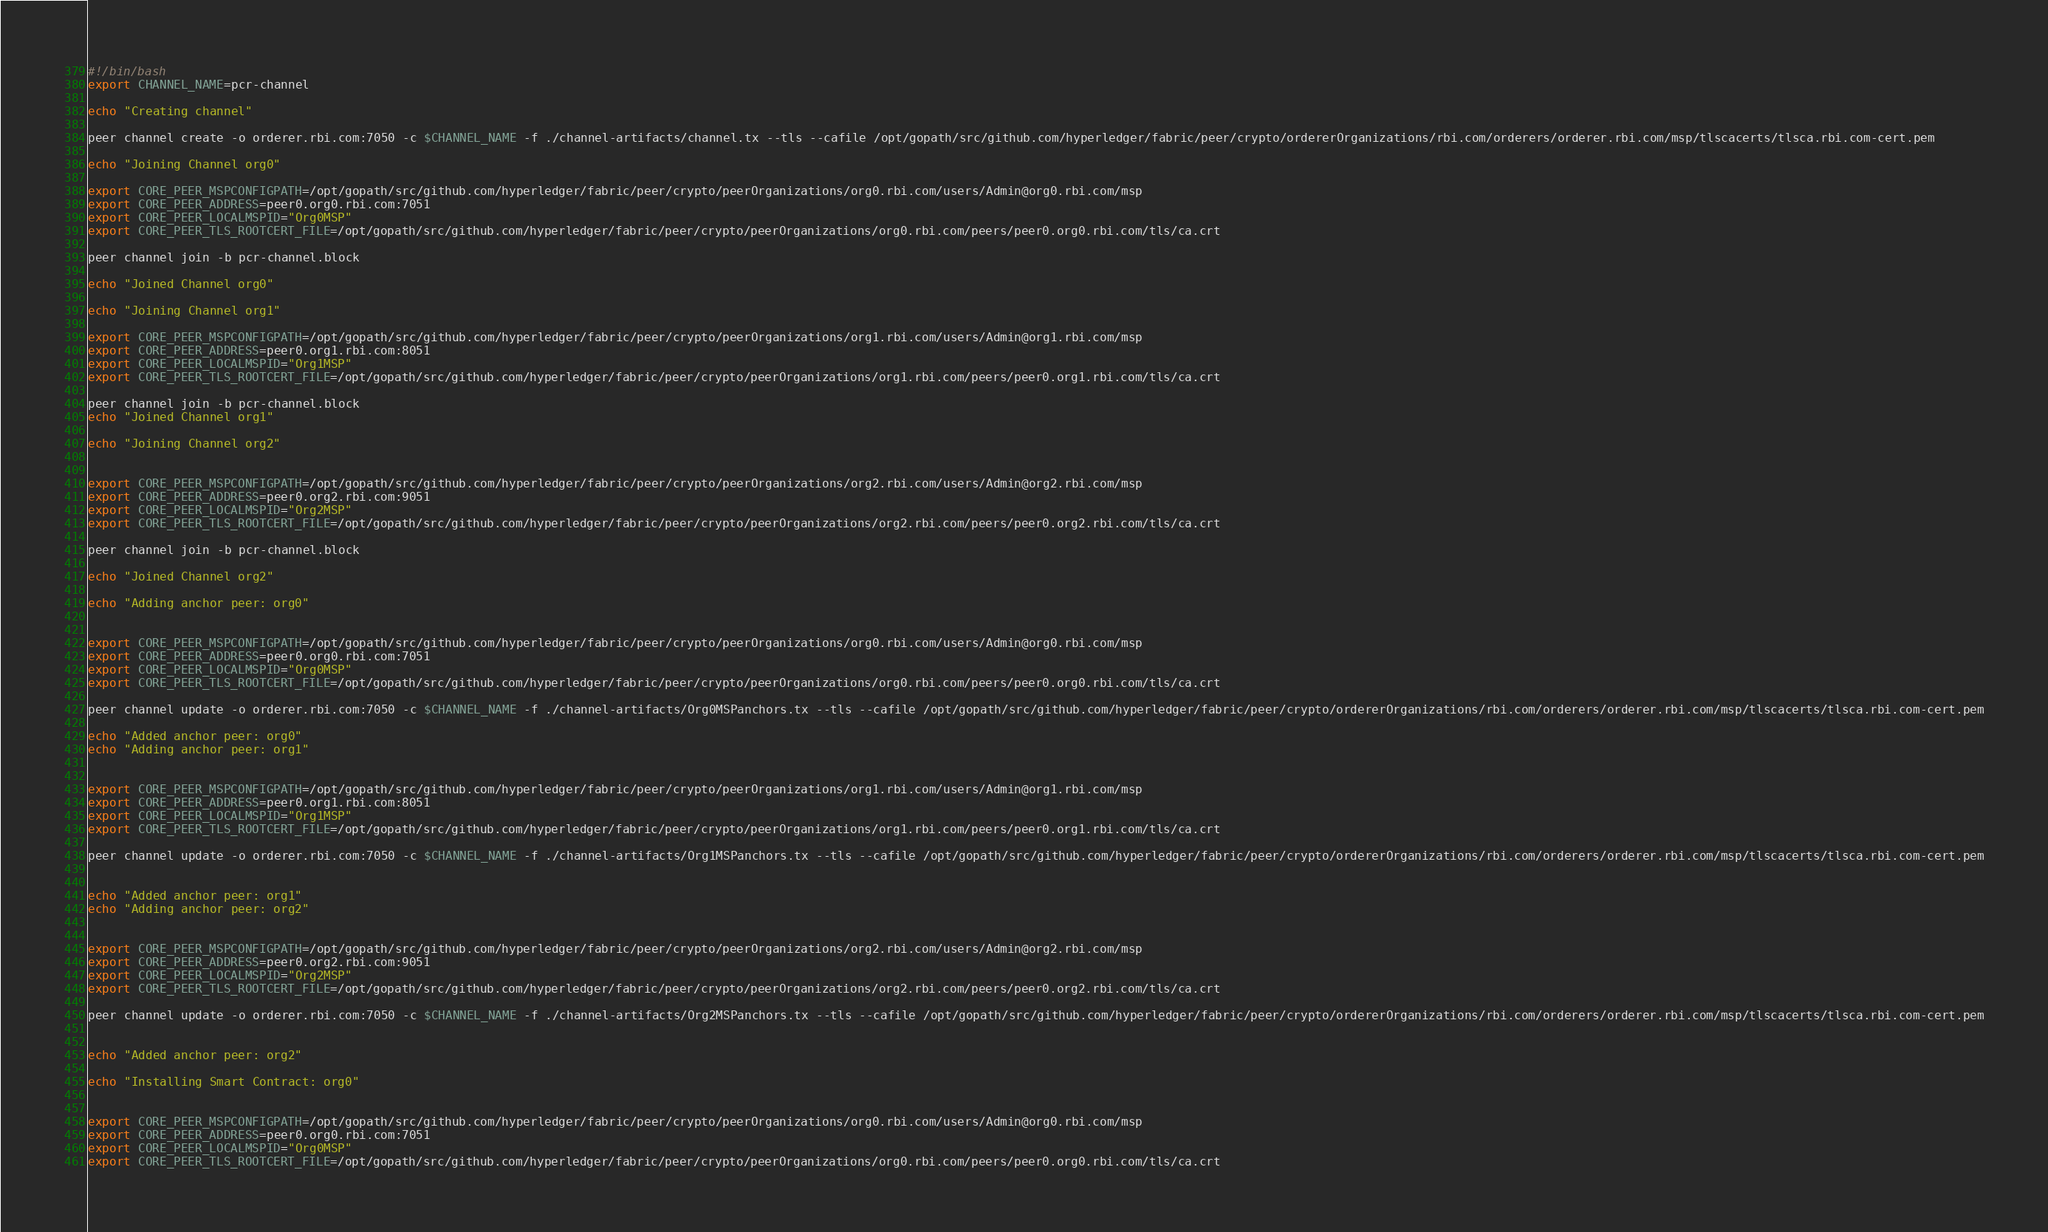<code> <loc_0><loc_0><loc_500><loc_500><_Bash_>#!/bin/bash
export CHANNEL_NAME=pcr-channel

echo "Creating channel"

peer channel create -o orderer.rbi.com:7050 -c $CHANNEL_NAME -f ./channel-artifacts/channel.tx --tls --cafile /opt/gopath/src/github.com/hyperledger/fabric/peer/crypto/ordererOrganizations/rbi.com/orderers/orderer.rbi.com/msp/tlscacerts/tlsca.rbi.com-cert.pem

echo "Joining Channel org0"

export CORE_PEER_MSPCONFIGPATH=/opt/gopath/src/github.com/hyperledger/fabric/peer/crypto/peerOrganizations/org0.rbi.com/users/Admin@org0.rbi.com/msp
export CORE_PEER_ADDRESS=peer0.org0.rbi.com:7051
export CORE_PEER_LOCALMSPID="Org0MSP"
export CORE_PEER_TLS_ROOTCERT_FILE=/opt/gopath/src/github.com/hyperledger/fabric/peer/crypto/peerOrganizations/org0.rbi.com/peers/peer0.org0.rbi.com/tls/ca.crt

peer channel join -b pcr-channel.block

echo "Joined Channel org0"

echo "Joining Channel org1"

export CORE_PEER_MSPCONFIGPATH=/opt/gopath/src/github.com/hyperledger/fabric/peer/crypto/peerOrganizations/org1.rbi.com/users/Admin@org1.rbi.com/msp
export CORE_PEER_ADDRESS=peer0.org1.rbi.com:8051
export CORE_PEER_LOCALMSPID="Org1MSP"
export CORE_PEER_TLS_ROOTCERT_FILE=/opt/gopath/src/github.com/hyperledger/fabric/peer/crypto/peerOrganizations/org1.rbi.com/peers/peer0.org1.rbi.com/tls/ca.crt

peer channel join -b pcr-channel.block
echo "Joined Channel org1"

echo "Joining Channel org2"


export CORE_PEER_MSPCONFIGPATH=/opt/gopath/src/github.com/hyperledger/fabric/peer/crypto/peerOrganizations/org2.rbi.com/users/Admin@org2.rbi.com/msp
export CORE_PEER_ADDRESS=peer0.org2.rbi.com:9051
export CORE_PEER_LOCALMSPID="Org2MSP"
export CORE_PEER_TLS_ROOTCERT_FILE=/opt/gopath/src/github.com/hyperledger/fabric/peer/crypto/peerOrganizations/org2.rbi.com/peers/peer0.org2.rbi.com/tls/ca.crt

peer channel join -b pcr-channel.block

echo "Joined Channel org2"

echo "Adding anchor peer: org0"


export CORE_PEER_MSPCONFIGPATH=/opt/gopath/src/github.com/hyperledger/fabric/peer/crypto/peerOrganizations/org0.rbi.com/users/Admin@org0.rbi.com/msp
export CORE_PEER_ADDRESS=peer0.org0.rbi.com:7051
export CORE_PEER_LOCALMSPID="Org0MSP"
export CORE_PEER_TLS_ROOTCERT_FILE=/opt/gopath/src/github.com/hyperledger/fabric/peer/crypto/peerOrganizations/org0.rbi.com/peers/peer0.org0.rbi.com/tls/ca.crt

peer channel update -o orderer.rbi.com:7050 -c $CHANNEL_NAME -f ./channel-artifacts/Org0MSPanchors.tx --tls --cafile /opt/gopath/src/github.com/hyperledger/fabric/peer/crypto/ordererOrganizations/rbi.com/orderers/orderer.rbi.com/msp/tlscacerts/tlsca.rbi.com-cert.pem

echo "Added anchor peer: org0"
echo "Adding anchor peer: org1"


export CORE_PEER_MSPCONFIGPATH=/opt/gopath/src/github.com/hyperledger/fabric/peer/crypto/peerOrganizations/org1.rbi.com/users/Admin@org1.rbi.com/msp
export CORE_PEER_ADDRESS=peer0.org1.rbi.com:8051
export CORE_PEER_LOCALMSPID="Org1MSP"
export CORE_PEER_TLS_ROOTCERT_FILE=/opt/gopath/src/github.com/hyperledger/fabric/peer/crypto/peerOrganizations/org1.rbi.com/peers/peer0.org1.rbi.com/tls/ca.crt

peer channel update -o orderer.rbi.com:7050 -c $CHANNEL_NAME -f ./channel-artifacts/Org1MSPanchors.tx --tls --cafile /opt/gopath/src/github.com/hyperledger/fabric/peer/crypto/ordererOrganizations/rbi.com/orderers/orderer.rbi.com/msp/tlscacerts/tlsca.rbi.com-cert.pem


echo "Added anchor peer: org1"
echo "Adding anchor peer: org2"


export CORE_PEER_MSPCONFIGPATH=/opt/gopath/src/github.com/hyperledger/fabric/peer/crypto/peerOrganizations/org2.rbi.com/users/Admin@org2.rbi.com/msp
export CORE_PEER_ADDRESS=peer0.org2.rbi.com:9051
export CORE_PEER_LOCALMSPID="Org2MSP"
export CORE_PEER_TLS_ROOTCERT_FILE=/opt/gopath/src/github.com/hyperledger/fabric/peer/crypto/peerOrganizations/org2.rbi.com/peers/peer0.org2.rbi.com/tls/ca.crt

peer channel update -o orderer.rbi.com:7050 -c $CHANNEL_NAME -f ./channel-artifacts/Org2MSPanchors.tx --tls --cafile /opt/gopath/src/github.com/hyperledger/fabric/peer/crypto/ordererOrganizations/rbi.com/orderers/orderer.rbi.com/msp/tlscacerts/tlsca.rbi.com-cert.pem


echo "Added anchor peer: org2"

echo "Installing Smart Contract: org0"


export CORE_PEER_MSPCONFIGPATH=/opt/gopath/src/github.com/hyperledger/fabric/peer/crypto/peerOrganizations/org0.rbi.com/users/Admin@org0.rbi.com/msp
export CORE_PEER_ADDRESS=peer0.org0.rbi.com:7051
export CORE_PEER_LOCALMSPID="Org0MSP"
export CORE_PEER_TLS_ROOTCERT_FILE=/opt/gopath/src/github.com/hyperledger/fabric/peer/crypto/peerOrganizations/org0.rbi.com/peers/peer0.org0.rbi.com/tls/ca.crt
</code> 